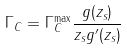<formula> <loc_0><loc_0><loc_500><loc_500>\Gamma _ { C } = \Gamma _ { C } ^ { \max } \frac { g ( z _ { s } ) } { z _ { s } g ^ { \prime } ( z _ { s } ) }</formula> 